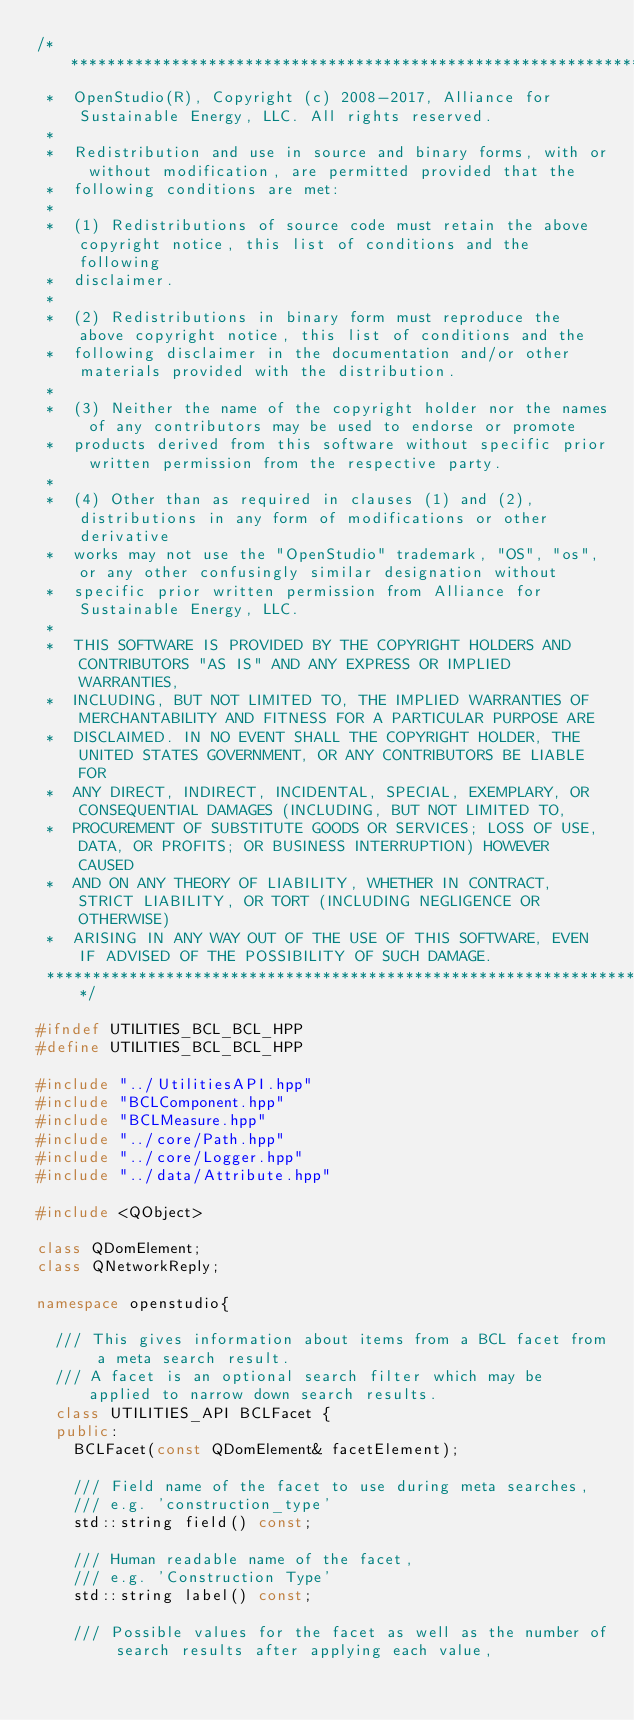Convert code to text. <code><loc_0><loc_0><loc_500><loc_500><_C++_>/***********************************************************************************************************************
 *  OpenStudio(R), Copyright (c) 2008-2017, Alliance for Sustainable Energy, LLC. All rights reserved.
 *
 *  Redistribution and use in source and binary forms, with or without modification, are permitted provided that the
 *  following conditions are met:
 *
 *  (1) Redistributions of source code must retain the above copyright notice, this list of conditions and the following
 *  disclaimer.
 *
 *  (2) Redistributions in binary form must reproduce the above copyright notice, this list of conditions and the
 *  following disclaimer in the documentation and/or other materials provided with the distribution.
 *
 *  (3) Neither the name of the copyright holder nor the names of any contributors may be used to endorse or promote
 *  products derived from this software without specific prior written permission from the respective party.
 *
 *  (4) Other than as required in clauses (1) and (2), distributions in any form of modifications or other derivative
 *  works may not use the "OpenStudio" trademark, "OS", "os", or any other confusingly similar designation without
 *  specific prior written permission from Alliance for Sustainable Energy, LLC.
 *
 *  THIS SOFTWARE IS PROVIDED BY THE COPYRIGHT HOLDERS AND CONTRIBUTORS "AS IS" AND ANY EXPRESS OR IMPLIED WARRANTIES,
 *  INCLUDING, BUT NOT LIMITED TO, THE IMPLIED WARRANTIES OF MERCHANTABILITY AND FITNESS FOR A PARTICULAR PURPOSE ARE
 *  DISCLAIMED. IN NO EVENT SHALL THE COPYRIGHT HOLDER, THE UNITED STATES GOVERNMENT, OR ANY CONTRIBUTORS BE LIABLE FOR
 *  ANY DIRECT, INDIRECT, INCIDENTAL, SPECIAL, EXEMPLARY, OR CONSEQUENTIAL DAMAGES (INCLUDING, BUT NOT LIMITED TO,
 *  PROCUREMENT OF SUBSTITUTE GOODS OR SERVICES; LOSS OF USE, DATA, OR PROFITS; OR BUSINESS INTERRUPTION) HOWEVER CAUSED
 *  AND ON ANY THEORY OF LIABILITY, WHETHER IN CONTRACT, STRICT LIABILITY, OR TORT (INCLUDING NEGLIGENCE OR OTHERWISE)
 *  ARISING IN ANY WAY OUT OF THE USE OF THIS SOFTWARE, EVEN IF ADVISED OF THE POSSIBILITY OF SUCH DAMAGE.
 **********************************************************************************************************************/

#ifndef UTILITIES_BCL_BCL_HPP
#define UTILITIES_BCL_BCL_HPP

#include "../UtilitiesAPI.hpp"
#include "BCLComponent.hpp"
#include "BCLMeasure.hpp"
#include "../core/Path.hpp"
#include "../core/Logger.hpp"
#include "../data/Attribute.hpp"

#include <QObject> 

class QDomElement;
class QNetworkReply;

namespace openstudio{

  /// This gives information about items from a BCL facet from a meta search result.
  /// A facet is an optional search filter which may be applied to narrow down search results.
  class UTILITIES_API BCLFacet {
  public:
    BCLFacet(const QDomElement& facetElement);

    /// Field name of the facet to use during meta searches,
    /// e.g. 'construction_type'
    std::string field() const;

    /// Human readable name of the facet,
    /// e.g. 'Construction Type'
    std::string label() const;

    /// Possible values for the facet as well as the number of search results after applying each value, </code> 